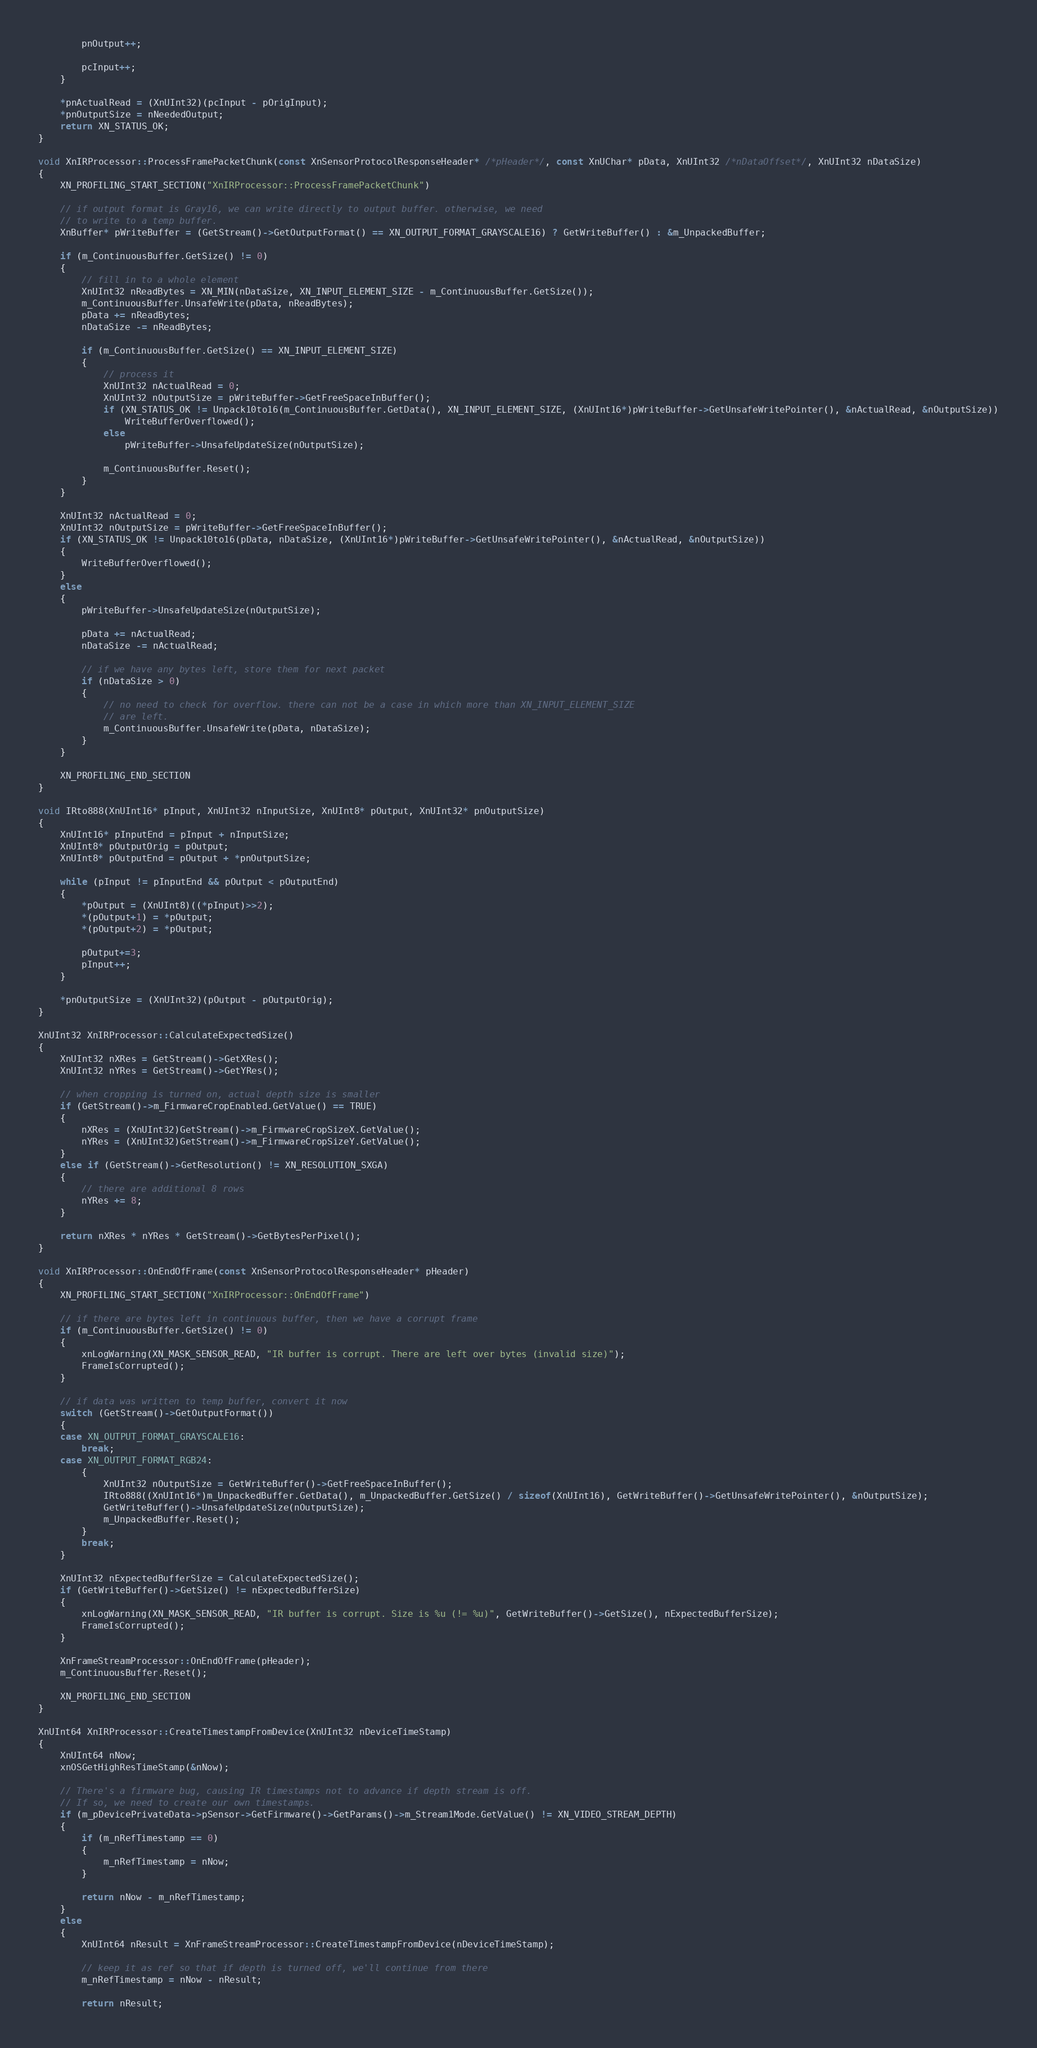Convert code to text. <code><loc_0><loc_0><loc_500><loc_500><_C++_>		pnOutput++;

		pcInput++;
	}

	*pnActualRead = (XnUInt32)(pcInput - pOrigInput);
	*pnOutputSize = nNeededOutput;
	return XN_STATUS_OK;
}

void XnIRProcessor::ProcessFramePacketChunk(const XnSensorProtocolResponseHeader* /*pHeader*/, const XnUChar* pData, XnUInt32 /*nDataOffset*/, XnUInt32 nDataSize)
{
	XN_PROFILING_START_SECTION("XnIRProcessor::ProcessFramePacketChunk")

	// if output format is Gray16, we can write directly to output buffer. otherwise, we need
	// to write to a temp buffer.
	XnBuffer* pWriteBuffer = (GetStream()->GetOutputFormat() == XN_OUTPUT_FORMAT_GRAYSCALE16) ? GetWriteBuffer() : &m_UnpackedBuffer;

	if (m_ContinuousBuffer.GetSize() != 0)
	{
		// fill in to a whole element
		XnUInt32 nReadBytes = XN_MIN(nDataSize, XN_INPUT_ELEMENT_SIZE - m_ContinuousBuffer.GetSize());
		m_ContinuousBuffer.UnsafeWrite(pData, nReadBytes);
		pData += nReadBytes;
		nDataSize -= nReadBytes;

		if (m_ContinuousBuffer.GetSize() == XN_INPUT_ELEMENT_SIZE)
		{
			// process it
			XnUInt32 nActualRead = 0;
			XnUInt32 nOutputSize = pWriteBuffer->GetFreeSpaceInBuffer();
			if (XN_STATUS_OK != Unpack10to16(m_ContinuousBuffer.GetData(), XN_INPUT_ELEMENT_SIZE, (XnUInt16*)pWriteBuffer->GetUnsafeWritePointer(), &nActualRead, &nOutputSize))
				WriteBufferOverflowed();
			else
				pWriteBuffer->UnsafeUpdateSize(nOutputSize);

			m_ContinuousBuffer.Reset();
		}
	}

	XnUInt32 nActualRead = 0;
	XnUInt32 nOutputSize = pWriteBuffer->GetFreeSpaceInBuffer();
	if (XN_STATUS_OK != Unpack10to16(pData, nDataSize, (XnUInt16*)pWriteBuffer->GetUnsafeWritePointer(), &nActualRead, &nOutputSize))
	{
		WriteBufferOverflowed();
	}
	else
	{
		pWriteBuffer->UnsafeUpdateSize(nOutputSize);

		pData += nActualRead;
		nDataSize -= nActualRead;

		// if we have any bytes left, store them for next packet
		if (nDataSize > 0)
		{
			// no need to check for overflow. there can not be a case in which more than XN_INPUT_ELEMENT_SIZE
			// are left.
			m_ContinuousBuffer.UnsafeWrite(pData, nDataSize);
		}
	}

	XN_PROFILING_END_SECTION
}

void IRto888(XnUInt16* pInput, XnUInt32 nInputSize, XnUInt8* pOutput, XnUInt32* pnOutputSize)
{
	XnUInt16* pInputEnd = pInput + nInputSize;
	XnUInt8* pOutputOrig = pOutput;
	XnUInt8* pOutputEnd = pOutput + *pnOutputSize;

	while (pInput != pInputEnd && pOutput < pOutputEnd)
	{
		*pOutput = (XnUInt8)((*pInput)>>2);
		*(pOutput+1) = *pOutput;
		*(pOutput+2) = *pOutput;

		pOutput+=3;
		pInput++;
	}

	*pnOutputSize = (XnUInt32)(pOutput - pOutputOrig);
}

XnUInt32 XnIRProcessor::CalculateExpectedSize()
{
	XnUInt32 nXRes = GetStream()->GetXRes();
	XnUInt32 nYRes = GetStream()->GetYRes();

	// when cropping is turned on, actual depth size is smaller
	if (GetStream()->m_FirmwareCropEnabled.GetValue() == TRUE)
	{
		nXRes = (XnUInt32)GetStream()->m_FirmwareCropSizeX.GetValue();
		nYRes = (XnUInt32)GetStream()->m_FirmwareCropSizeY.GetValue();
	}
	else if (GetStream()->GetResolution() != XN_RESOLUTION_SXGA)
	{
		// there are additional 8 rows
		nYRes += 8;
	}

	return nXRes * nYRes * GetStream()->GetBytesPerPixel();
}

void XnIRProcessor::OnEndOfFrame(const XnSensorProtocolResponseHeader* pHeader)
{
	XN_PROFILING_START_SECTION("XnIRProcessor::OnEndOfFrame")

	// if there are bytes left in continuous buffer, then we have a corrupt frame
	if (m_ContinuousBuffer.GetSize() != 0)
	{
		xnLogWarning(XN_MASK_SENSOR_READ, "IR buffer is corrupt. There are left over bytes (invalid size)");
		FrameIsCorrupted();
	}

	// if data was written to temp buffer, convert it now
	switch (GetStream()->GetOutputFormat())
	{
	case XN_OUTPUT_FORMAT_GRAYSCALE16:
		break;
	case XN_OUTPUT_FORMAT_RGB24:
		{
			XnUInt32 nOutputSize = GetWriteBuffer()->GetFreeSpaceInBuffer();
			IRto888((XnUInt16*)m_UnpackedBuffer.GetData(), m_UnpackedBuffer.GetSize() / sizeof(XnUInt16), GetWriteBuffer()->GetUnsafeWritePointer(), &nOutputSize);
			GetWriteBuffer()->UnsafeUpdateSize(nOutputSize);
			m_UnpackedBuffer.Reset();
		}
		break;
	}

	XnUInt32 nExpectedBufferSize = CalculateExpectedSize();
	if (GetWriteBuffer()->GetSize() != nExpectedBufferSize)
	{
		xnLogWarning(XN_MASK_SENSOR_READ, "IR buffer is corrupt. Size is %u (!= %u)", GetWriteBuffer()->GetSize(), nExpectedBufferSize);
		FrameIsCorrupted();
	}

	XnFrameStreamProcessor::OnEndOfFrame(pHeader);
	m_ContinuousBuffer.Reset();

	XN_PROFILING_END_SECTION
}

XnUInt64 XnIRProcessor::CreateTimestampFromDevice(XnUInt32 nDeviceTimeStamp)
{
	XnUInt64 nNow;
	xnOSGetHighResTimeStamp(&nNow);

	// There's a firmware bug, causing IR timestamps not to advance if depth stream is off.
	// If so, we need to create our own timestamps.
	if (m_pDevicePrivateData->pSensor->GetFirmware()->GetParams()->m_Stream1Mode.GetValue() != XN_VIDEO_STREAM_DEPTH)
	{
		if (m_nRefTimestamp == 0)
		{
			m_nRefTimestamp = nNow;
		}

		return nNow - m_nRefTimestamp;
	}
	else
	{
		XnUInt64 nResult = XnFrameStreamProcessor::CreateTimestampFromDevice(nDeviceTimeStamp);

		// keep it as ref so that if depth is turned off, we'll continue from there
		m_nRefTimestamp = nNow - nResult;

		return nResult;</code> 